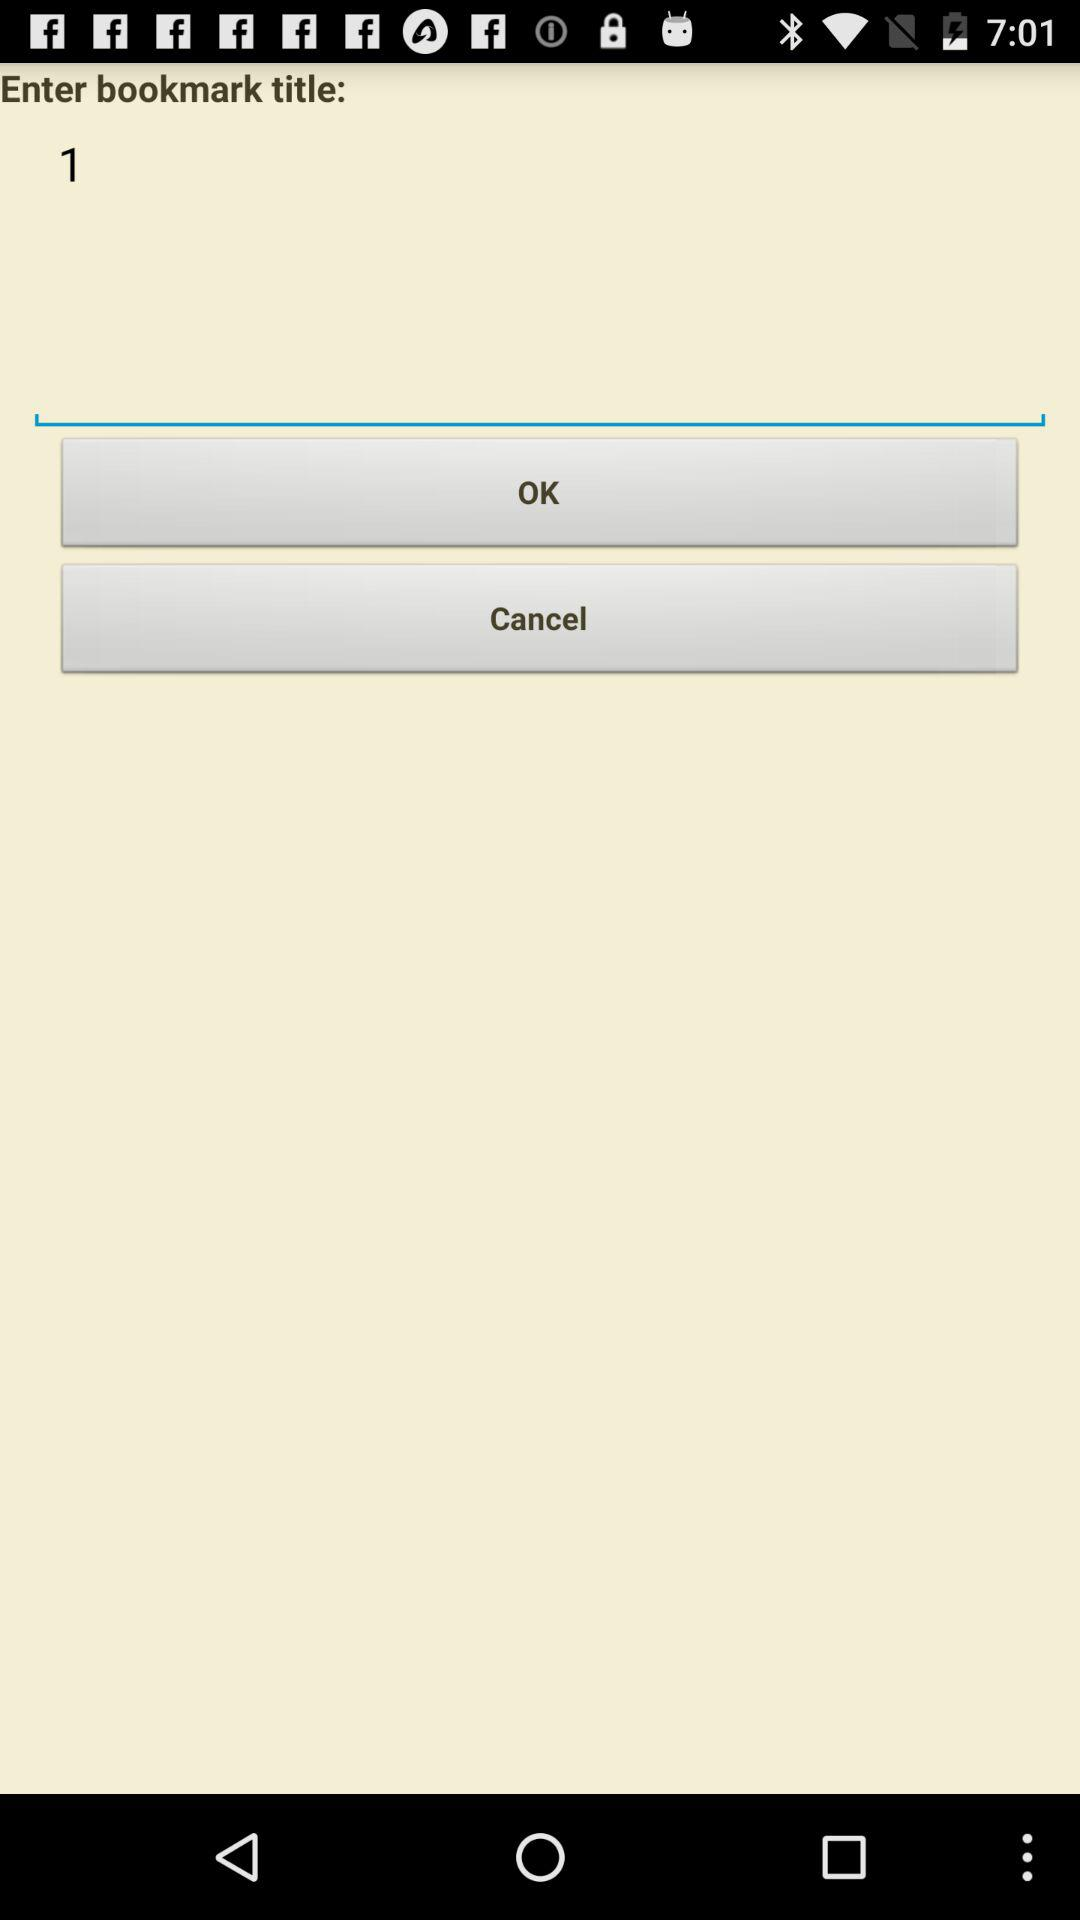What is the bookmark title? The bookmark title is 1. 